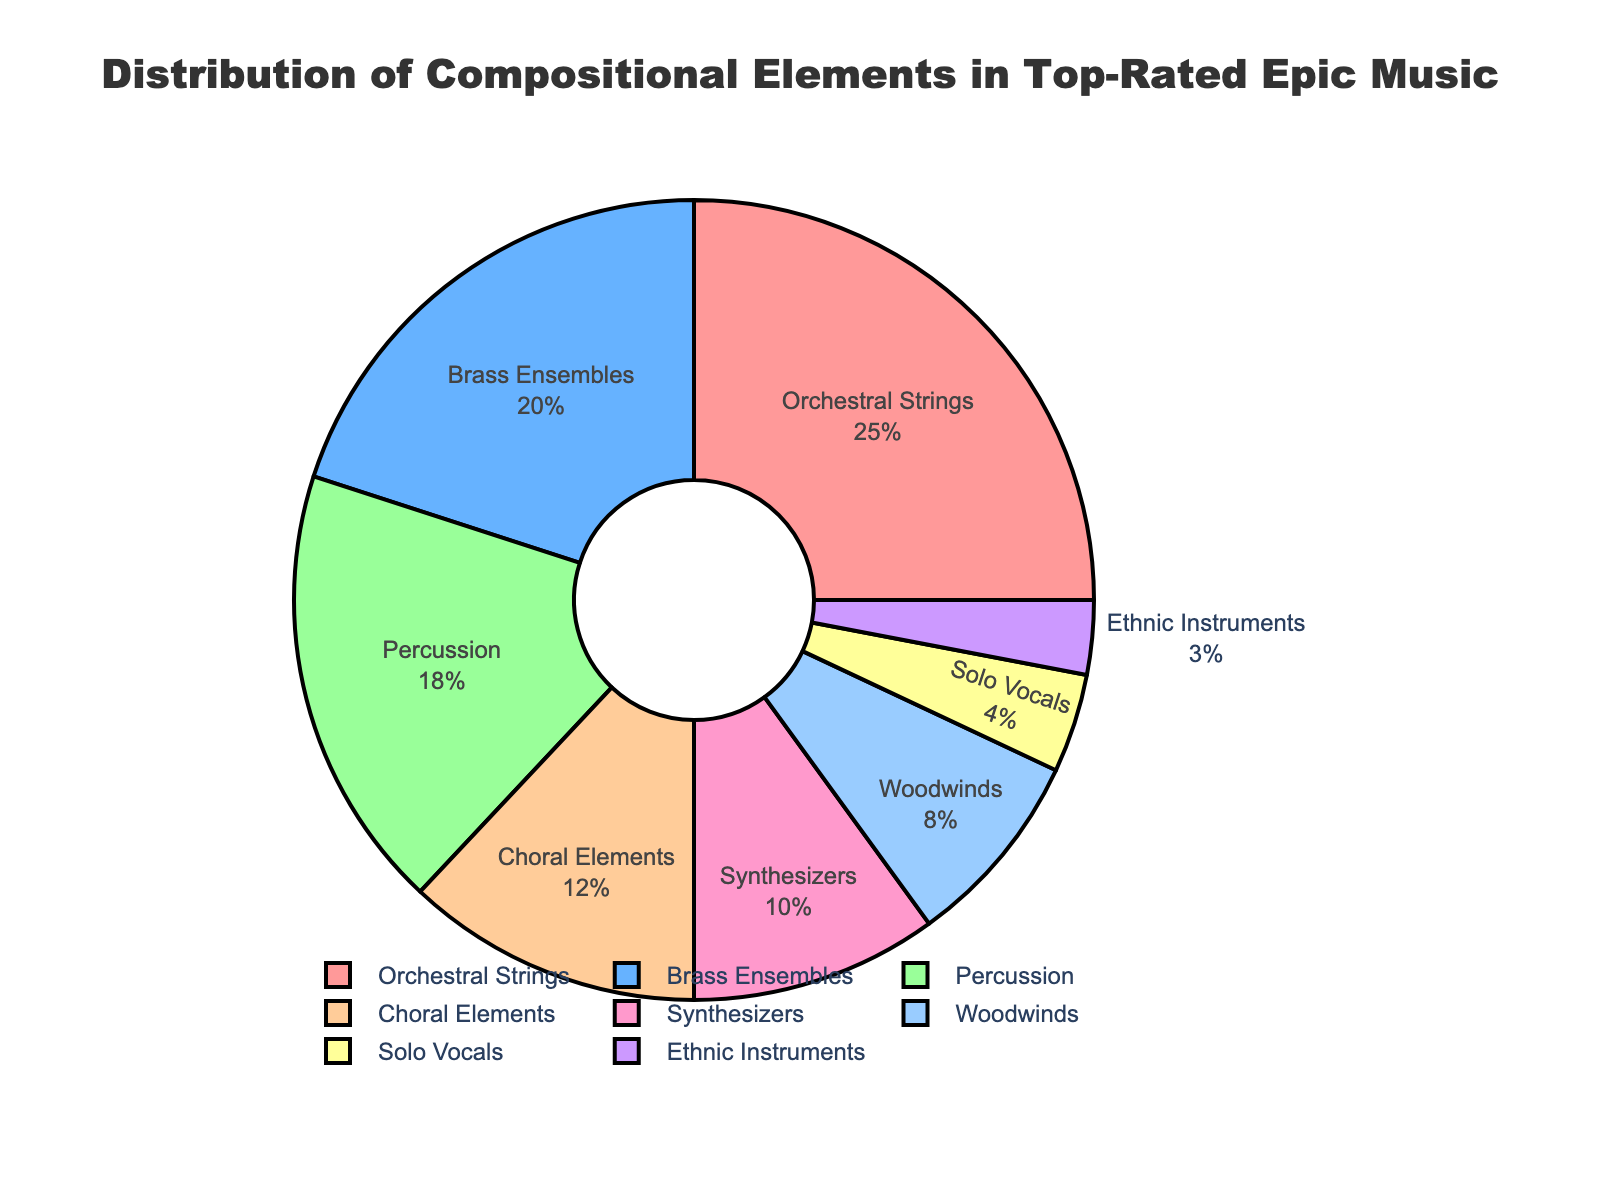What percentage of the chart is taken up by Orchestral Strings and Brass Ensembles combined? Orchestral Strings take up 25% and Brass Ensembles take up 20%. Adding these percentages gives us 25% + 20% = 45%.
Answer: 45% Which category has a smaller percentage: Synthesizers or Woodwinds? Synthesizers take up 10% of the chart, and Woodwinds take up 8%. Since 8% is less than 10%, Woodwinds occupy a smaller percentage.
Answer: Woodwinds How many categories have a percentage of 10% or higher? The categories with percentages 10% or higher are Orchestral Strings (25%), Brass Ensembles (20%), Percussion (18%), and Synthesizers (10%). There are 4 such categories.
Answer: 4 What is the difference in percentage between the highest and lowest categories? The highest category is Orchestral Strings at 25% and the lowest is Ethnic Instruments at 3%. The difference is 25% - 3% = 22%.
Answer: 22% Which color represents Choral Elements in the pie chart? Choral Elements should be the fourth category based on the order of colors applied. The color representing Choral Elements is likely a light orange or peach color since it follows the pattern of colors.
Answer: Light orange/peach How does the percentage of Solo Vocals compare to the percentage of Choral Elements? Choral Elements take up 12% of the chart, whereas Solo Vocals take up 4%. Hence, Choral Elements have a higher percentage than Solo Vocals.
Answer: Choral Elements have a higher percentage What is the average percentage for Orchestral Strings, Brass Ensembles, and Choral Elements? The percentages for these categories are 25%, 20%, and 12%, respectively. The average is calculated as (25% + 20% + 12%) / 3 ≈ 19%.
Answer: 19% If you combine Woodwinds and Ethnic Instruments, would their combined percentage be greater than Synthesizers? Woodwinds have 8% and Ethnic Instruments have 3%. Together, they make up 8% + 3% = 11%, which is greater than the 10% for Synthesizers.
Answer: Yes, it's greater What percentage slice is represented by the least used compositional element? The least used compositional element is Ethnic Instruments, which takes up 3% of the pie chart.
Answer: 3% Which category has a percentage closest to that of Percussion? Percussion takes up 18% of the chart. Brass Ensembles take up 20%, which is the closest percentage to 18% when compared with other categories.
Answer: Brass Ensembles 